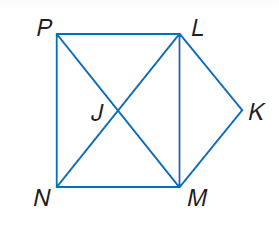Answer the mathemtical geometry problem and directly provide the correct option letter.
Question: Use rectangle L M N P, parallelogram L K M J to solve the problem. If m \angle L M P = m \angle P M N, find m \angle P J L.
Choices: A: 30 B: 45 C: 60 D: 90 D 